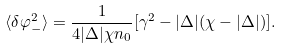Convert formula to latex. <formula><loc_0><loc_0><loc_500><loc_500>\langle \delta \varphi _ { - } ^ { 2 } \rangle = \frac { 1 } { 4 | \Delta | \chi n _ { 0 } } [ \gamma ^ { 2 } - | \Delta | ( \chi - | \Delta | ) ] .</formula> 